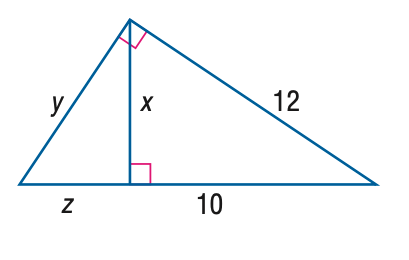Answer the mathemtical geometry problem and directly provide the correct option letter.
Question: Find y.
Choices: A: \frac { 6 } { 5 } B: \frac { 12 } { 5 } C: \frac { 6 } { 5 } \sqrt { 11 } D: \frac { 12 } { 5 } \sqrt { 11 } D 